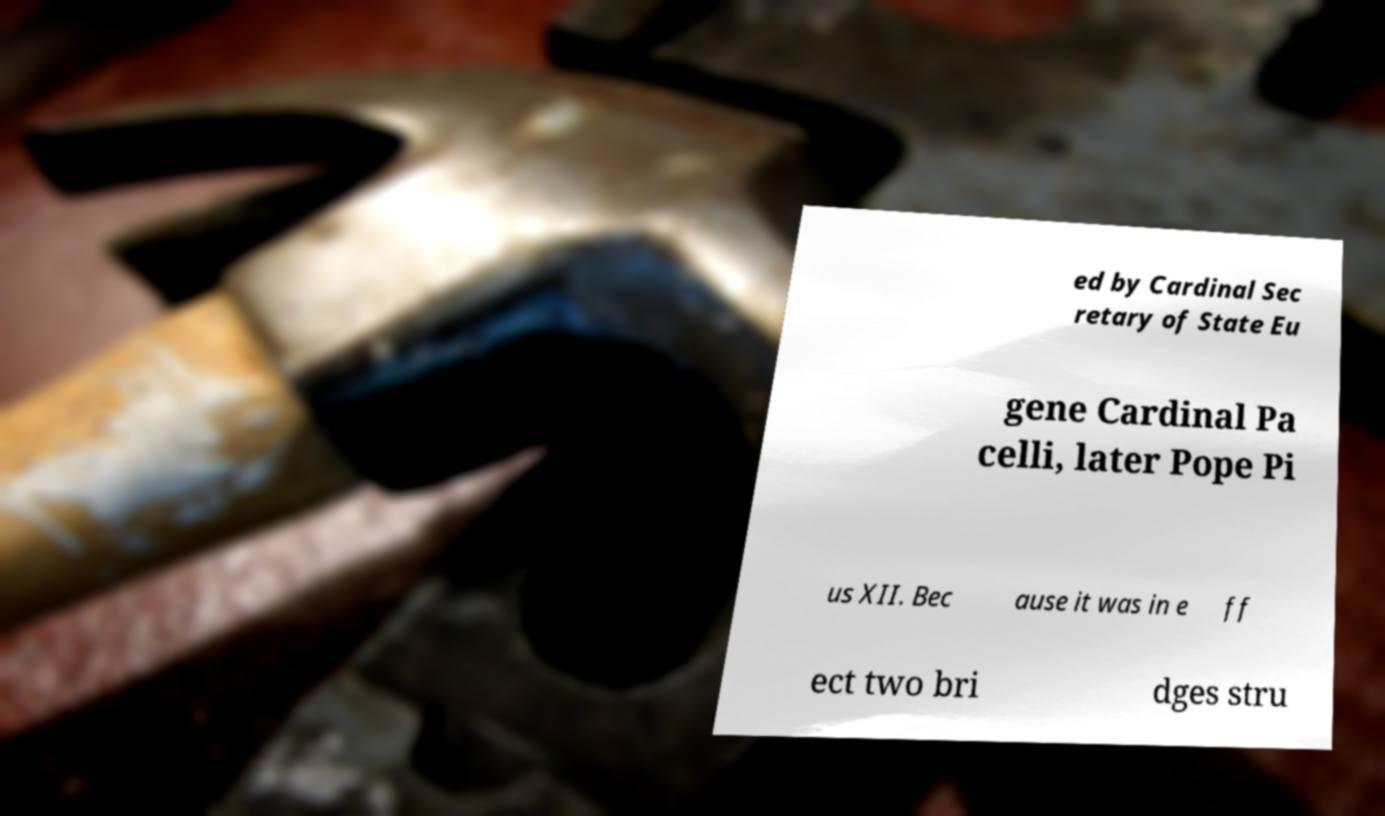What messages or text are displayed in this image? I need them in a readable, typed format. ed by Cardinal Sec retary of State Eu gene Cardinal Pa celli, later Pope Pi us XII. Bec ause it was in e ff ect two bri dges stru 